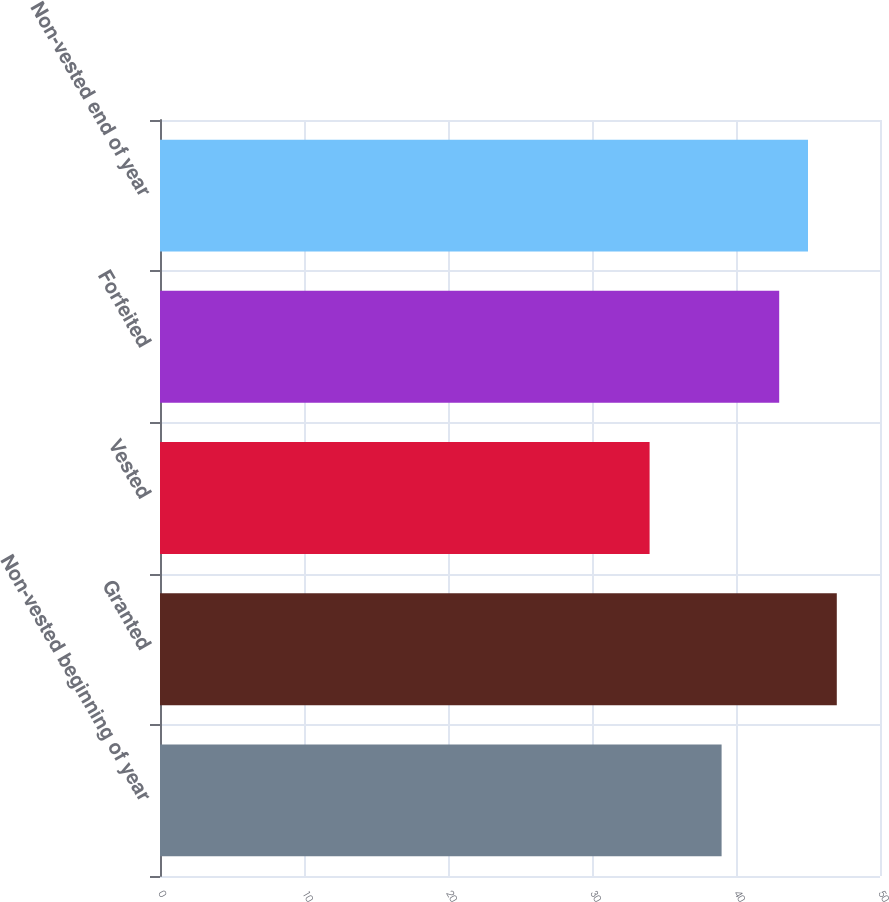Convert chart. <chart><loc_0><loc_0><loc_500><loc_500><bar_chart><fcel>Non-vested beginning of year<fcel>Granted<fcel>Vested<fcel>Forfeited<fcel>Non-vested end of year<nl><fcel>39<fcel>47<fcel>34<fcel>43<fcel>45<nl></chart> 